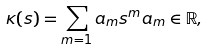Convert formula to latex. <formula><loc_0><loc_0><loc_500><loc_500>\kappa ( s ) = \sum _ { m = 1 } a _ { m } s ^ { m } a _ { m } \in \mathbb { R } ,</formula> 